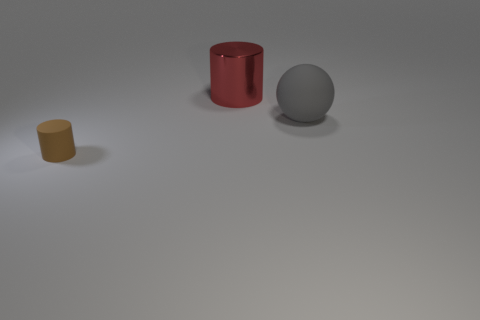Add 2 big gray rubber balls. How many objects exist? 5 Subtract all red cylinders. How many cylinders are left? 1 Subtract all yellow cylinders. Subtract all green blocks. How many cylinders are left? 2 Add 3 large shiny objects. How many large shiny objects are left? 4 Add 2 tiny brown matte objects. How many tiny brown matte objects exist? 3 Subtract 0 purple blocks. How many objects are left? 3 Subtract all cylinders. How many objects are left? 1 Subtract all large yellow matte things. Subtract all matte things. How many objects are left? 1 